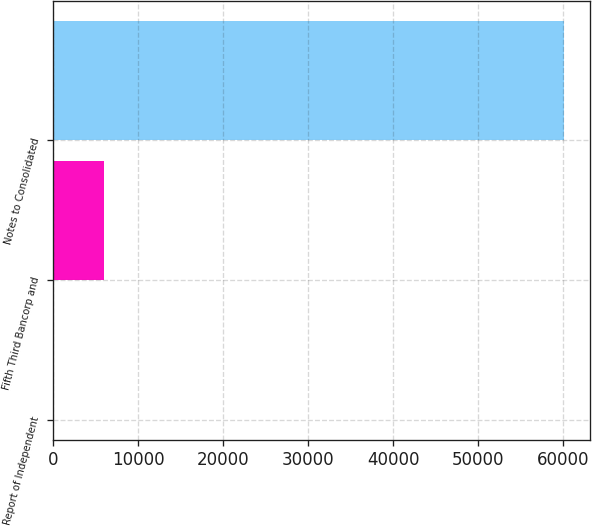<chart> <loc_0><loc_0><loc_500><loc_500><bar_chart><fcel>Report of Independent<fcel>Fifth Third Bancorp and<fcel>Notes to Consolidated<nl><fcel>55<fcel>6059.5<fcel>60100<nl></chart> 